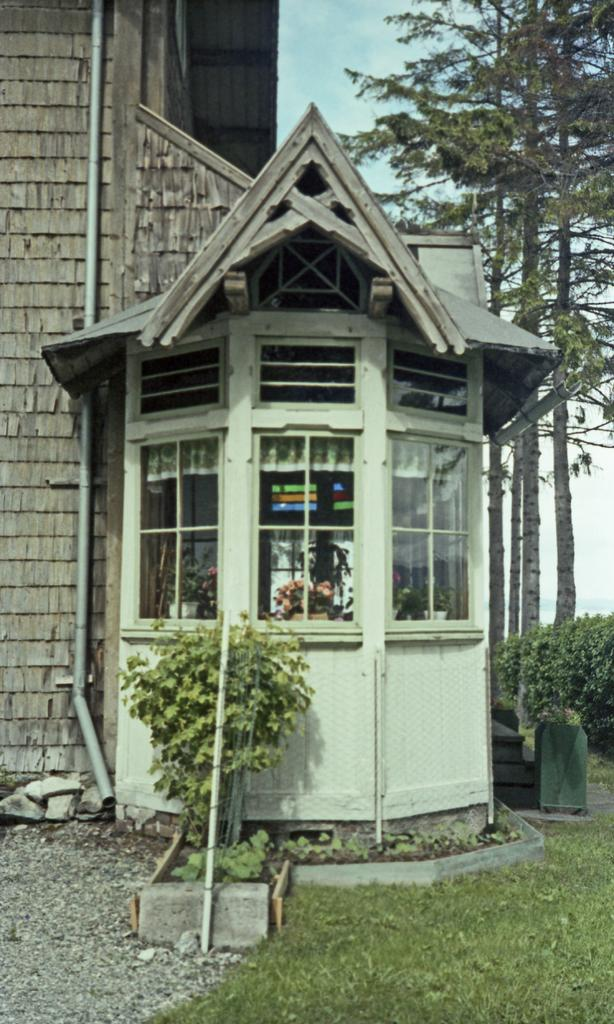What type of structure is visible in the image? There is a house in the image. What material is used for the pipes on the house? The house has plastic pipes. What type of windows are on the house? The house has glass windows. What is located in front of the house? There is a plant in front of the house. What type of vegetation is beside the house? There are bushes and trees beside the house. What type of crack can be seen on the jar in the image? There is no jar or crack present in the image; it features a house with plastic pipes, glass windows, and surrounding vegetation. How many cakes are visible on the table in the image? There is no table or cakes present in the image; it features a house with a plant in front and bushes and trees beside it. 